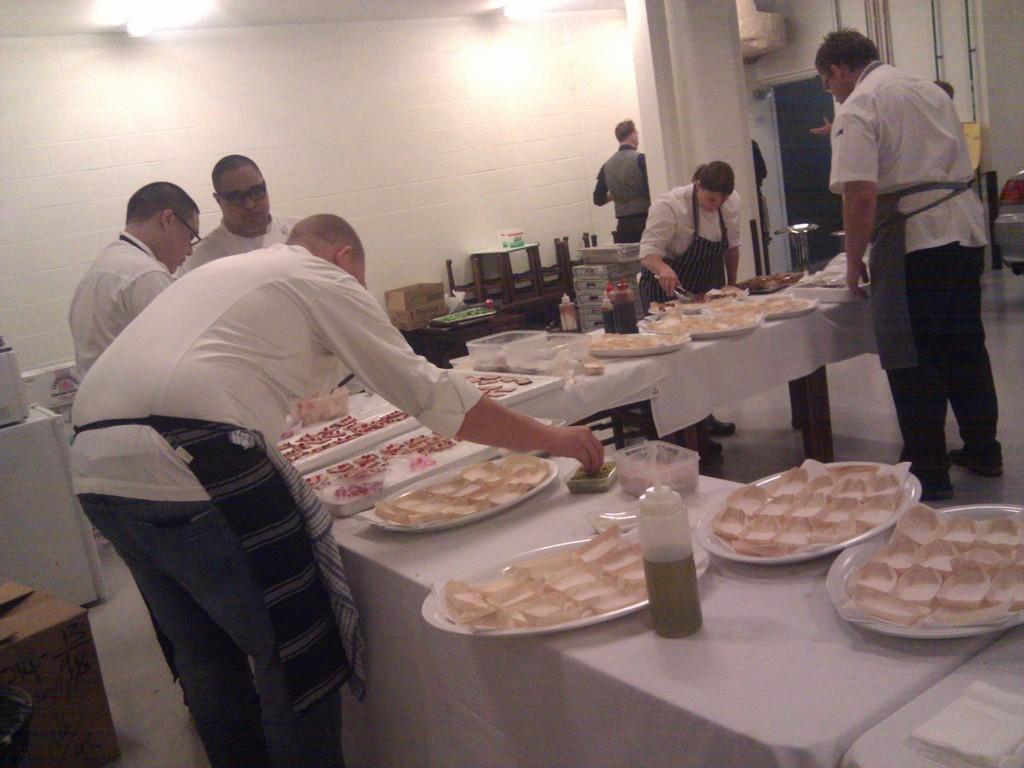Describe this image in one or two sentences. In this image we can see some group of persons preparing food and some are serving food and there are some food items which are kept in plates on table and in the background of the image there are some boxes, chairs and there is a wall. 